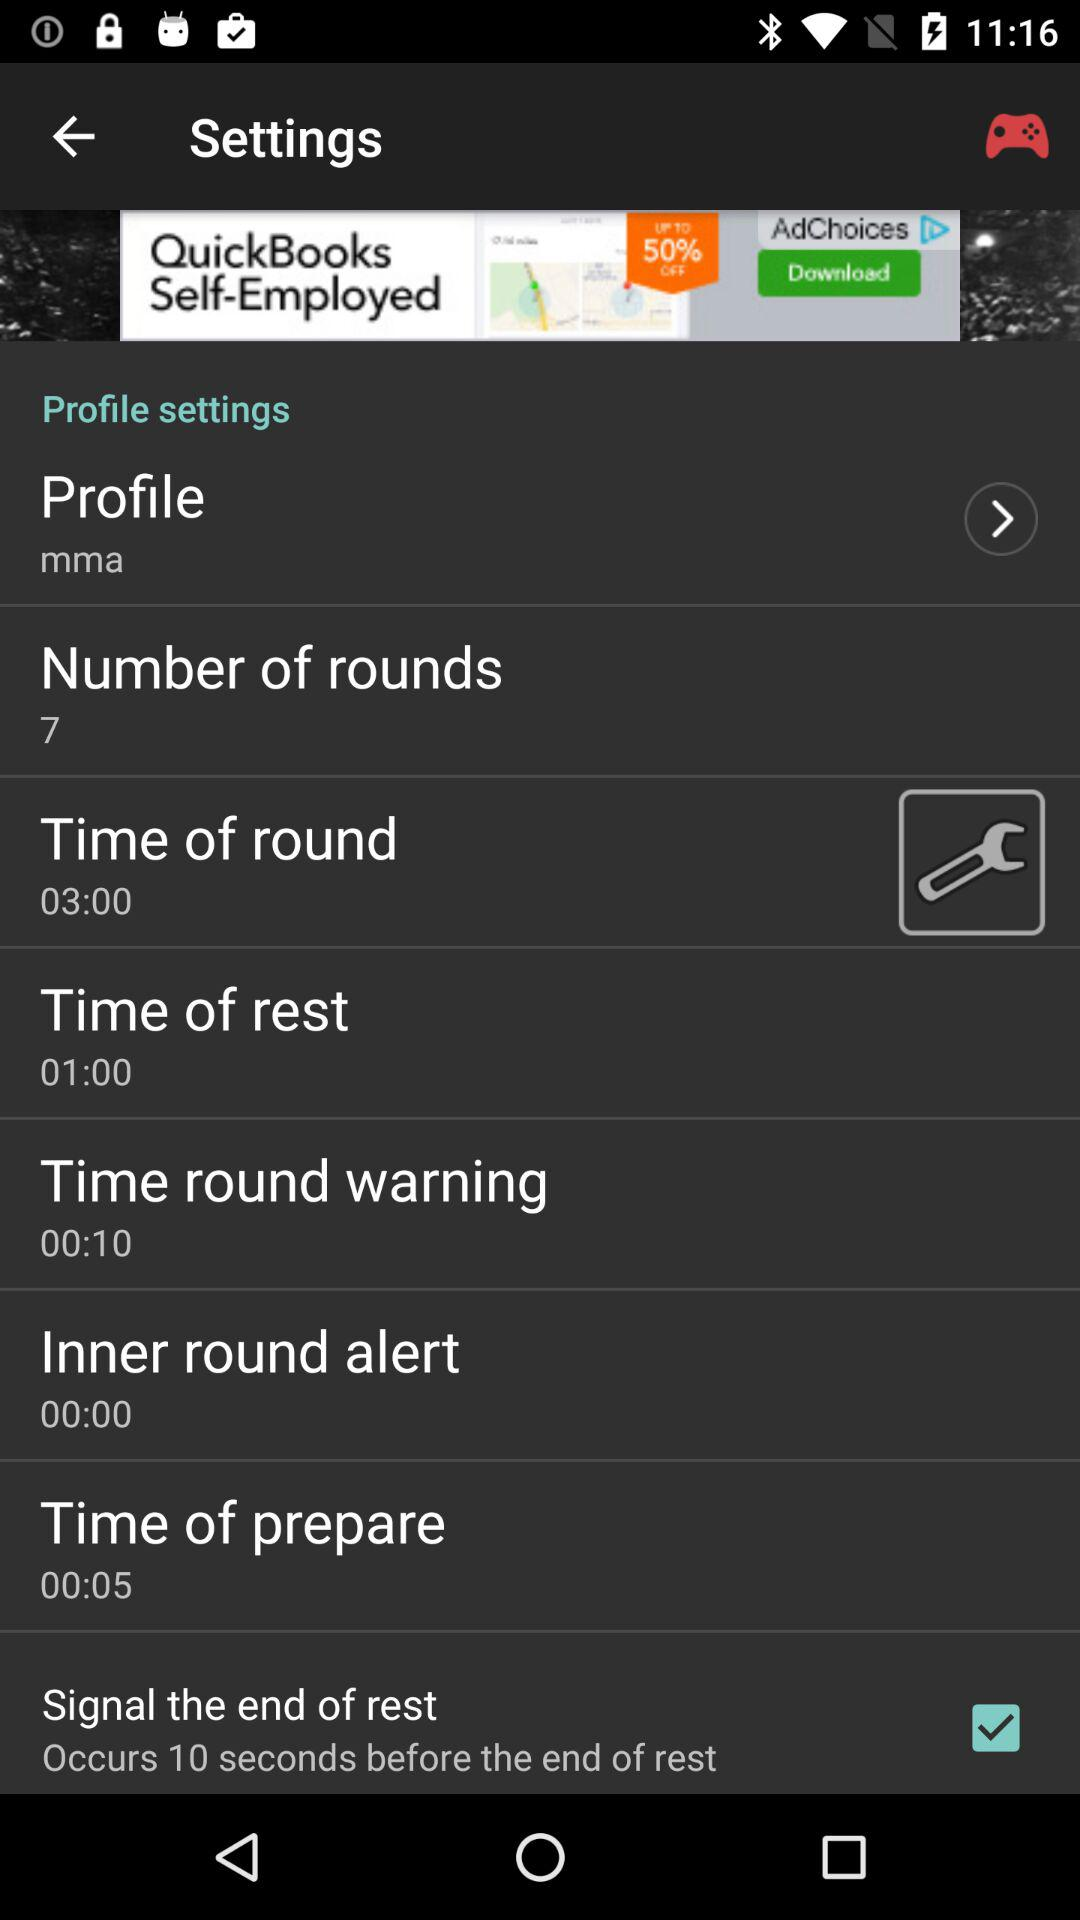What is the preparation time? The preparation time is 5 seconds. 